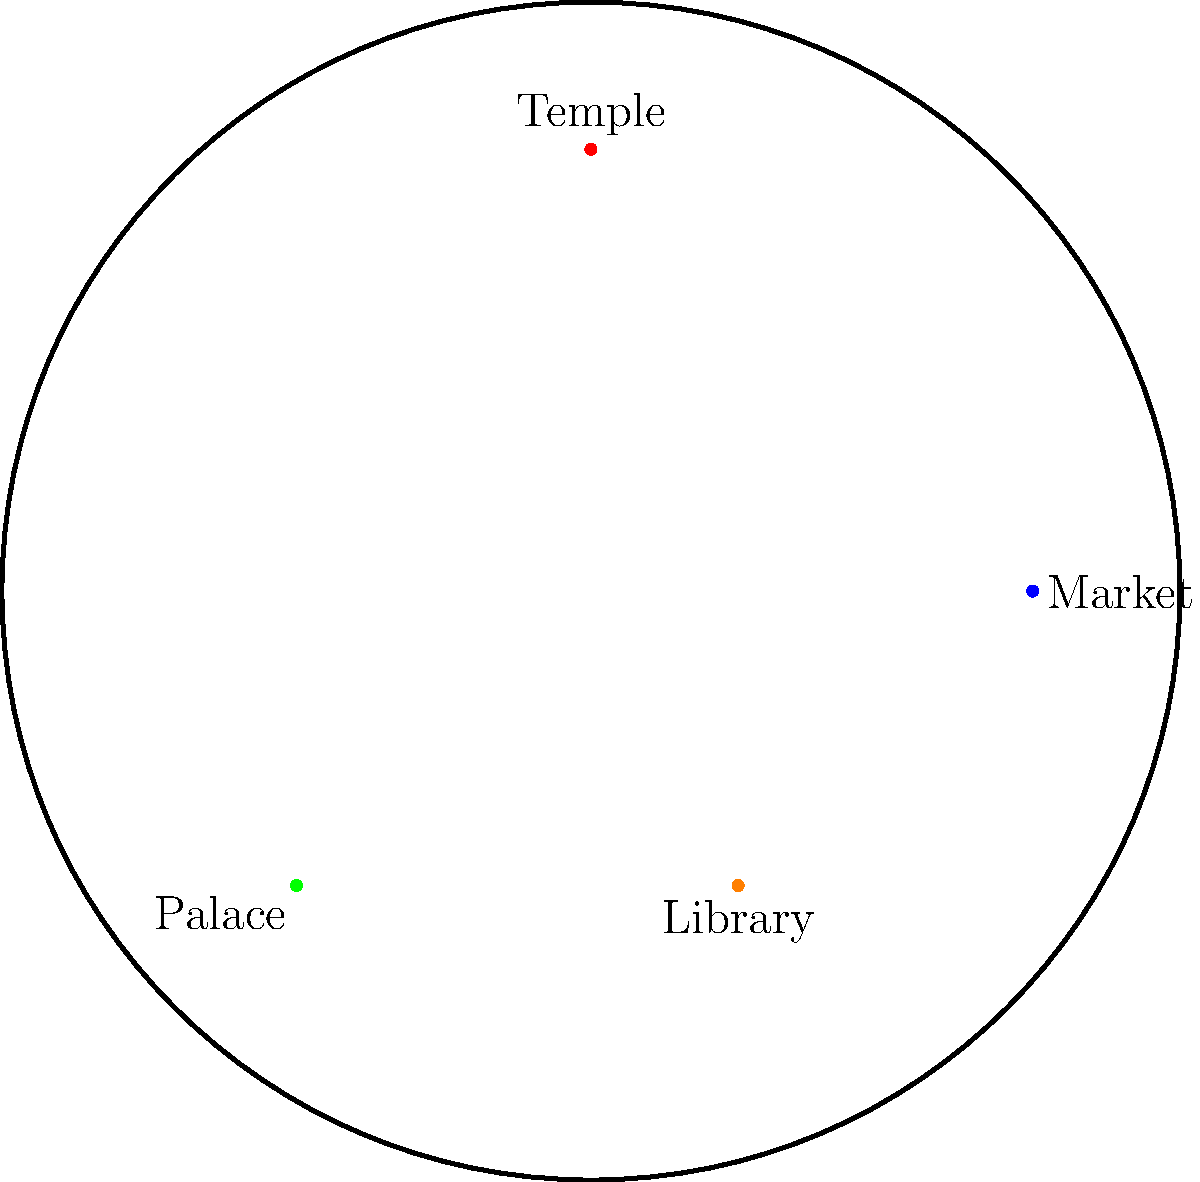Study the map of this ancient city for 30 seconds, then close your eyes and try to recall the positions of the landmarks. Which landmark is located in the southwestern quadrant of the city, closest to the river? To answer this question, we need to follow these steps:

1. Identify the quadrants of the city:
   - The city is circular, so we can divide it into four quadrants using the cardinal directions.
   - The river runs horizontally through the southern part of the city, helping us orient the map.

2. Locate the southwestern quadrant:
   - This would be the lower-left quarter of the circular city map.

3. Identify the landmarks in the southwestern quadrant:
   - The Palace is clearly in the southwestern quadrant.
   - The Library is in the southern part but slightly to the east of the center.

4. Determine which landmark is closest to the river:
   - The Palace is located at (-2,-2), which is closer to the river (y = -1) than the Library at (1,-2).

5. Confirm the answer:
   - The Palace is both in the southwestern quadrant and closest to the river among the landmarks in that area.

This spatial memory test challenges the student's ability to mentally visualize and recall the layout of an ancient city, which aligns with their interest in history and nostalgia for analog methods of studying and remembering information.
Answer: Palace 